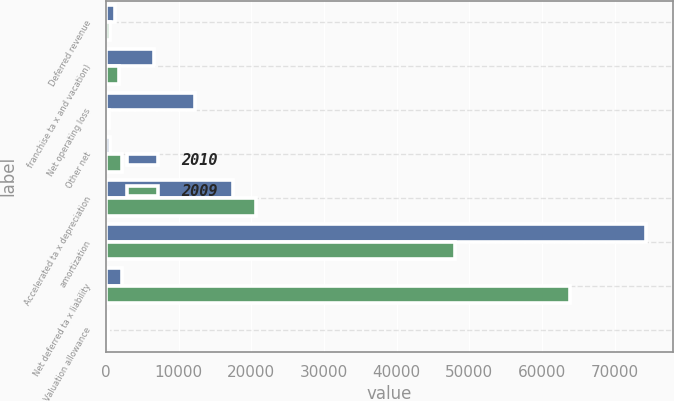<chart> <loc_0><loc_0><loc_500><loc_500><stacked_bar_chart><ecel><fcel>Deferred revenue<fcel>franchise ta x and vacation)<fcel>Net operating loss<fcel>Other net<fcel>Accelerated ta x depreciation<fcel>amortization<fcel>Net deferred ta x liability<fcel>Valuation allowance<nl><fcel>2010<fcel>1198<fcel>6591<fcel>12222<fcel>514<fcel>17425<fcel>74341<fcel>2273<fcel>306<nl><fcel>2009<fcel>577<fcel>1834<fcel>401<fcel>2273<fcel>20579<fcel>47995<fcel>63907<fcel>277<nl></chart> 